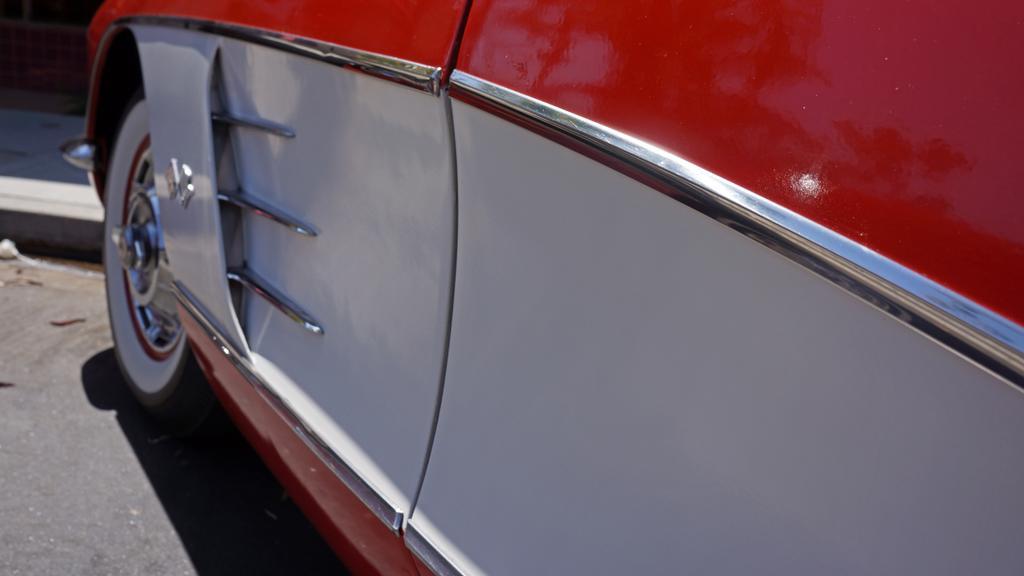How would you summarize this image in a sentence or two? In this image I can see a car. A wheel of a car and a door which is red and white color. 